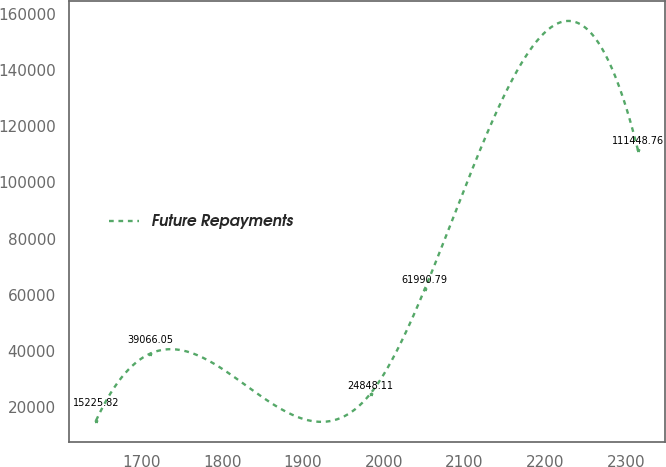<chart> <loc_0><loc_0><loc_500><loc_500><line_chart><ecel><fcel>Future Repayments<nl><fcel>1643.53<fcel>15225.8<nl><fcel>1710.65<fcel>39066.1<nl><fcel>1983.52<fcel>24848.1<nl><fcel>2050.64<fcel>61990.8<nl><fcel>2314.74<fcel>111449<nl></chart> 